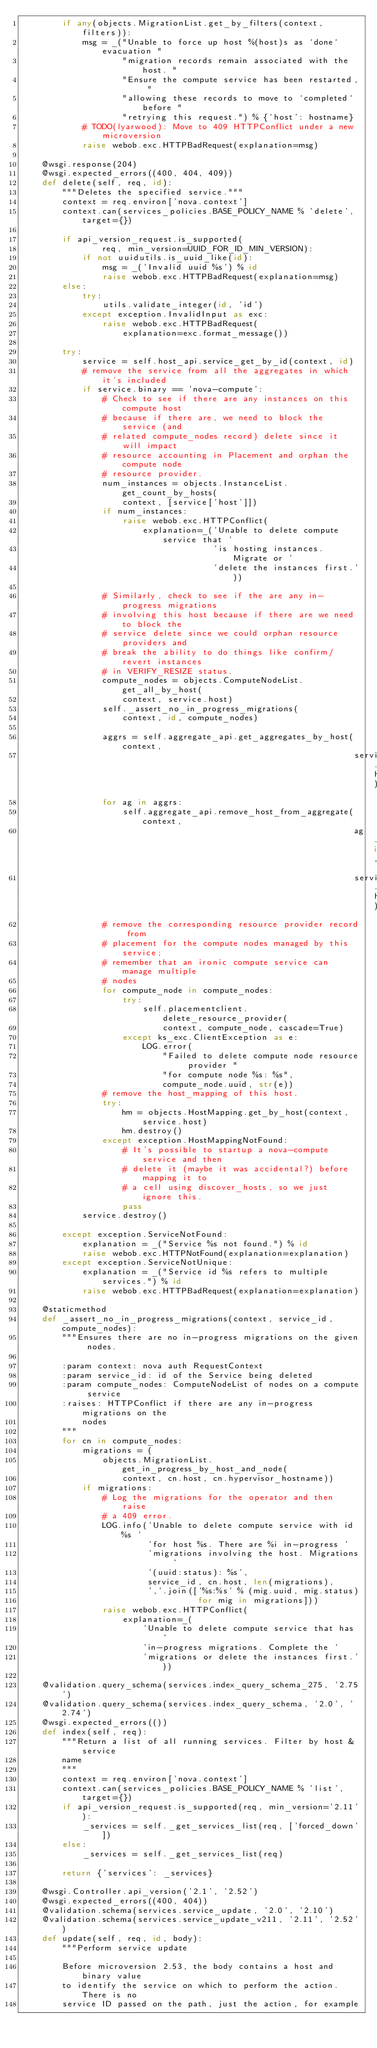<code> <loc_0><loc_0><loc_500><loc_500><_Python_>        if any(objects.MigrationList.get_by_filters(context, filters)):
            msg = _("Unable to force up host %(host)s as `done` evacuation "
                    "migration records remain associated with the host. "
                    "Ensure the compute service has been restarted, "
                    "allowing these records to move to `completed` before "
                    "retrying this request.") % {'host': hostname}
            # TODO(lyarwood): Move to 409 HTTPConflict under a new microversion
            raise webob.exc.HTTPBadRequest(explanation=msg)

    @wsgi.response(204)
    @wsgi.expected_errors((400, 404, 409))
    def delete(self, req, id):
        """Deletes the specified service."""
        context = req.environ['nova.context']
        context.can(services_policies.BASE_POLICY_NAME % 'delete', target={})

        if api_version_request.is_supported(
                req, min_version=UUID_FOR_ID_MIN_VERSION):
            if not uuidutils.is_uuid_like(id):
                msg = _('Invalid uuid %s') % id
                raise webob.exc.HTTPBadRequest(explanation=msg)
        else:
            try:
                utils.validate_integer(id, 'id')
            except exception.InvalidInput as exc:
                raise webob.exc.HTTPBadRequest(
                    explanation=exc.format_message())

        try:
            service = self.host_api.service_get_by_id(context, id)
            # remove the service from all the aggregates in which it's included
            if service.binary == 'nova-compute':
                # Check to see if there are any instances on this compute host
                # because if there are, we need to block the service (and
                # related compute_nodes record) delete since it will impact
                # resource accounting in Placement and orphan the compute node
                # resource provider.
                num_instances = objects.InstanceList.get_count_by_hosts(
                    context, [service['host']])
                if num_instances:
                    raise webob.exc.HTTPConflict(
                        explanation=_('Unable to delete compute service that '
                                      'is hosting instances. Migrate or '
                                      'delete the instances first.'))

                # Similarly, check to see if the are any in-progress migrations
                # involving this host because if there are we need to block the
                # service delete since we could orphan resource providers and
                # break the ability to do things like confirm/revert instances
                # in VERIFY_RESIZE status.
                compute_nodes = objects.ComputeNodeList.get_all_by_host(
                    context, service.host)
                self._assert_no_in_progress_migrations(
                    context, id, compute_nodes)

                aggrs = self.aggregate_api.get_aggregates_by_host(context,
                                                                  service.host)
                for ag in aggrs:
                    self.aggregate_api.remove_host_from_aggregate(context,
                                                                  ag.id,
                                                                  service.host)
                # remove the corresponding resource provider record from
                # placement for the compute nodes managed by this service;
                # remember that an ironic compute service can manage multiple
                # nodes
                for compute_node in compute_nodes:
                    try:
                        self.placementclient.delete_resource_provider(
                            context, compute_node, cascade=True)
                    except ks_exc.ClientException as e:
                        LOG.error(
                            "Failed to delete compute node resource provider "
                            "for compute node %s: %s",
                            compute_node.uuid, str(e))
                # remove the host_mapping of this host.
                try:
                    hm = objects.HostMapping.get_by_host(context, service.host)
                    hm.destroy()
                except exception.HostMappingNotFound:
                    # It's possible to startup a nova-compute service and then
                    # delete it (maybe it was accidental?) before mapping it to
                    # a cell using discover_hosts, so we just ignore this.
                    pass
            service.destroy()

        except exception.ServiceNotFound:
            explanation = _("Service %s not found.") % id
            raise webob.exc.HTTPNotFound(explanation=explanation)
        except exception.ServiceNotUnique:
            explanation = _("Service id %s refers to multiple services.") % id
            raise webob.exc.HTTPBadRequest(explanation=explanation)

    @staticmethod
    def _assert_no_in_progress_migrations(context, service_id, compute_nodes):
        """Ensures there are no in-progress migrations on the given nodes.

        :param context: nova auth RequestContext
        :param service_id: id of the Service being deleted
        :param compute_nodes: ComputeNodeList of nodes on a compute service
        :raises: HTTPConflict if there are any in-progress migrations on the
            nodes
        """
        for cn in compute_nodes:
            migrations = (
                objects.MigrationList.get_in_progress_by_host_and_node(
                    context, cn.host, cn.hypervisor_hostname))
            if migrations:
                # Log the migrations for the operator and then raise
                # a 409 error.
                LOG.info('Unable to delete compute service with id %s '
                         'for host %s. There are %i in-progress '
                         'migrations involving the host. Migrations '
                         '(uuid:status): %s',
                         service_id, cn.host, len(migrations),
                         ','.join(['%s:%s' % (mig.uuid, mig.status)
                                   for mig in migrations]))
                raise webob.exc.HTTPConflict(
                    explanation=_(
                        'Unable to delete compute service that has '
                        'in-progress migrations. Complete the '
                        'migrations or delete the instances first.'))

    @validation.query_schema(services.index_query_schema_275, '2.75')
    @validation.query_schema(services.index_query_schema, '2.0', '2.74')
    @wsgi.expected_errors(())
    def index(self, req):
        """Return a list of all running services. Filter by host & service
        name
        """
        context = req.environ['nova.context']
        context.can(services_policies.BASE_POLICY_NAME % 'list', target={})
        if api_version_request.is_supported(req, min_version='2.11'):
            _services = self._get_services_list(req, ['forced_down'])
        else:
            _services = self._get_services_list(req)

        return {'services': _services}

    @wsgi.Controller.api_version('2.1', '2.52')
    @wsgi.expected_errors((400, 404))
    @validation.schema(services.service_update, '2.0', '2.10')
    @validation.schema(services.service_update_v211, '2.11', '2.52')
    def update(self, req, id, body):
        """Perform service update

        Before microversion 2.53, the body contains a host and binary value
        to identify the service on which to perform the action. There is no
        service ID passed on the path, just the action, for example</code> 